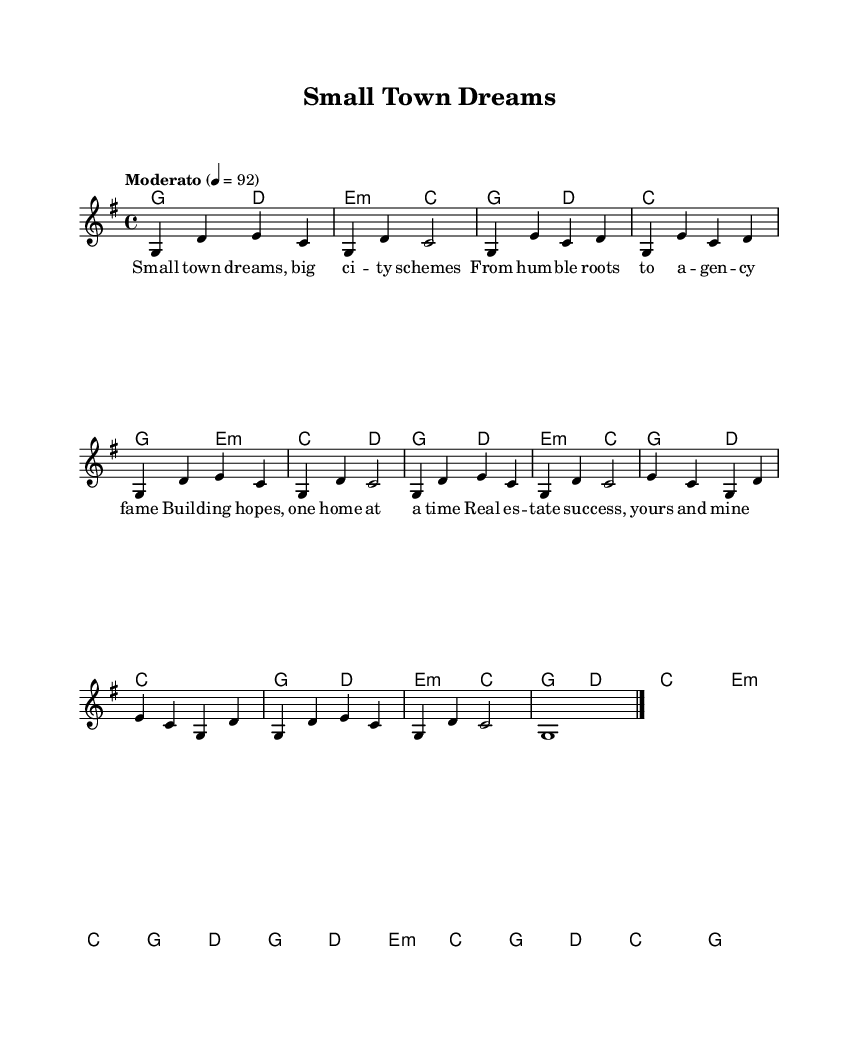What is the key signature of this music? The key signature is G major, which contains one sharp (F#). It can be identified by looking at the key signature at the beginning of the staff.
Answer: G major What is the time signature of this music? The time signature is 4/4, indicated by the "4/4" notation at the beginning of the piece. This means there are four beats in each measure.
Answer: 4/4 What is the tempo marking of this music? The tempo marking is "Moderato", along with a metronome marking of 92 beats per minute, which indicates a moderate pace for the music. This is given at the start of the score.
Answer: Moderato How many bars are there in the chorus? The chorus consists of eight bars, as indicated in the score where the melodic and harmonic lines are repeated for the chorus section.
Answer: Eight What is the structure of the song? The song has an intro, verses, a chorus, a bridge, and an outro, allowing it to follow a typical folk song structure that emphasizes storytelling. This can be inferred by observing the labels and arrangement of sections in the music.
Answer: Intro, Verse, Chorus, Bridge, Outro What theme is represented in the lyrics? The theme of the lyrics celebrates small-town success stories, highlighting the growth from modest beginnings to achievements in real estate and community development. This is evident from the lyrics provided in relation to the title and tone of the song.
Answer: Small-town success What type of lyrics does this folk song employ? The song uses narrative lyrics, which tell a story about dreams, achievements, and real estate success in a small town, a common characteristic of folk music aimed at representing personal and community experiences. This can be determined from the lyrical content provided in the score.
Answer: Narrative 